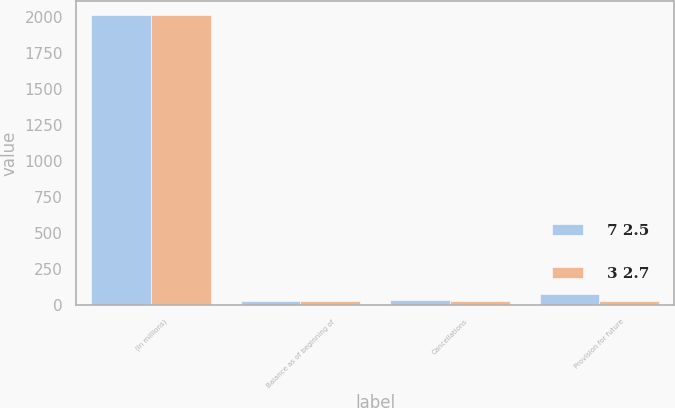Convert chart to OTSL. <chart><loc_0><loc_0><loc_500><loc_500><stacked_bar_chart><ecel><fcel>(In millions)<fcel>Balance as of beginning of<fcel>Cancellations<fcel>Provision for future<nl><fcel>7 2.5<fcel>2014<fcel>32.7<fcel>36.9<fcel>76.7<nl><fcel>3 2.7<fcel>2013<fcel>28.5<fcel>27.5<fcel>31.7<nl></chart> 